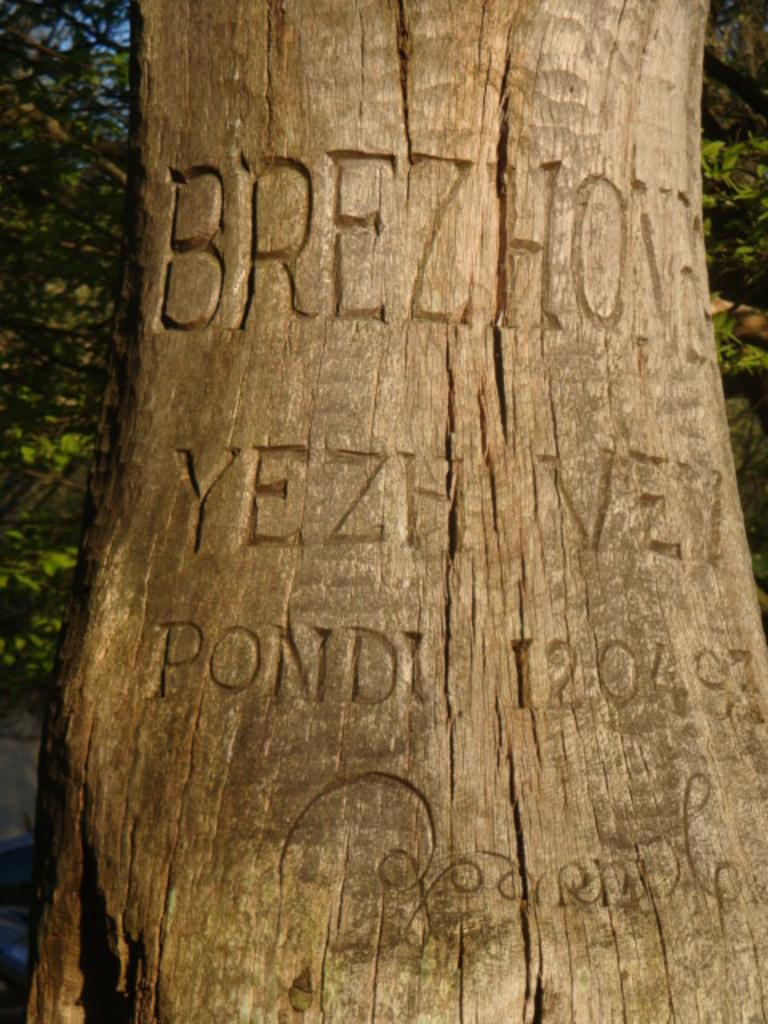What is the main subject of the image? There is a carving on a tree in the center of the image. What can be seen in the background of the image? There are trees in the background of the image. What is visible beneath the tree and carving? The ground is visible in the image. What part of the sky is visible in the image? The sky is visible in the top left corner of the image. What type of list can be seen hanging from the tree in the image? There is no list present in the image; it features a carving on a tree. Is there any snow or indication of winter in the image? There is no snow or indication of winter in the image; the focus is on the carving and the surrounding environment. 